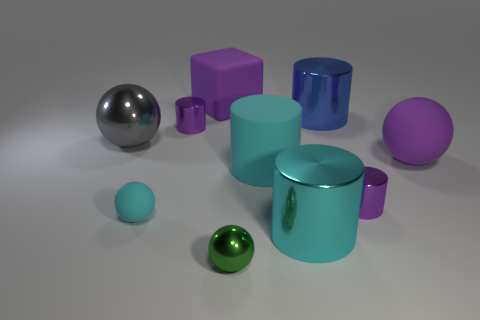Subtract all cyan balls. How many balls are left? 3 Subtract all cyan cylinders. How many cylinders are left? 3 Subtract all balls. How many objects are left? 6 Subtract all purple balls. Subtract all purple cylinders. How many balls are left? 3 Subtract all purple cylinders. How many gray balls are left? 1 Subtract all large cyan things. Subtract all spheres. How many objects are left? 4 Add 5 green things. How many green things are left? 6 Add 7 gray cubes. How many gray cubes exist? 7 Subtract 0 cyan blocks. How many objects are left? 10 Subtract 1 blocks. How many blocks are left? 0 